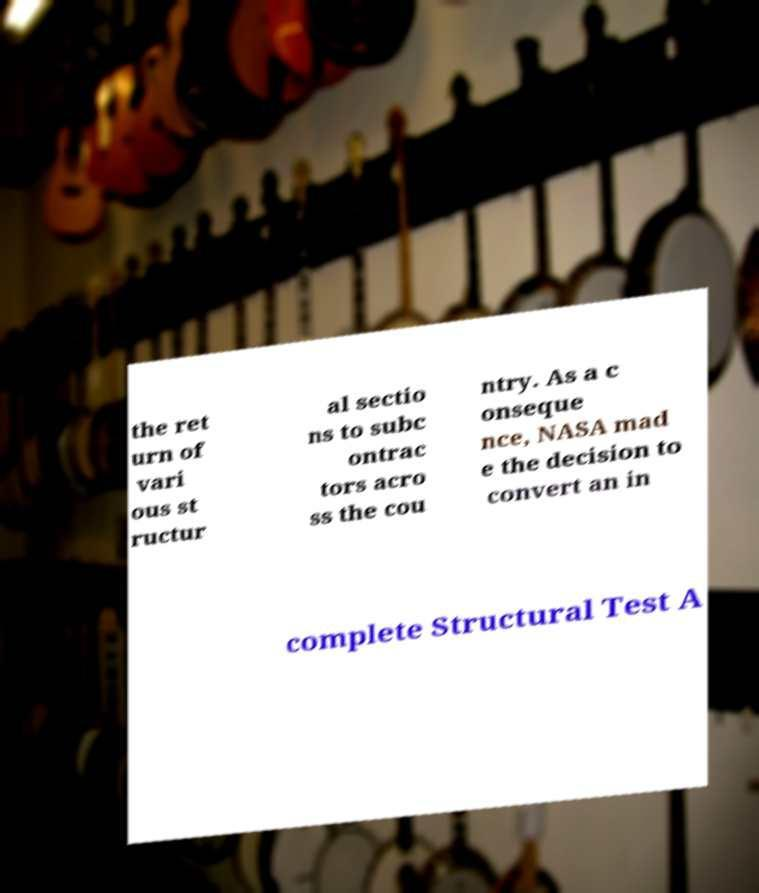I need the written content from this picture converted into text. Can you do that? the ret urn of vari ous st ructur al sectio ns to subc ontrac tors acro ss the cou ntry. As a c onseque nce, NASA mad e the decision to convert an in complete Structural Test A 